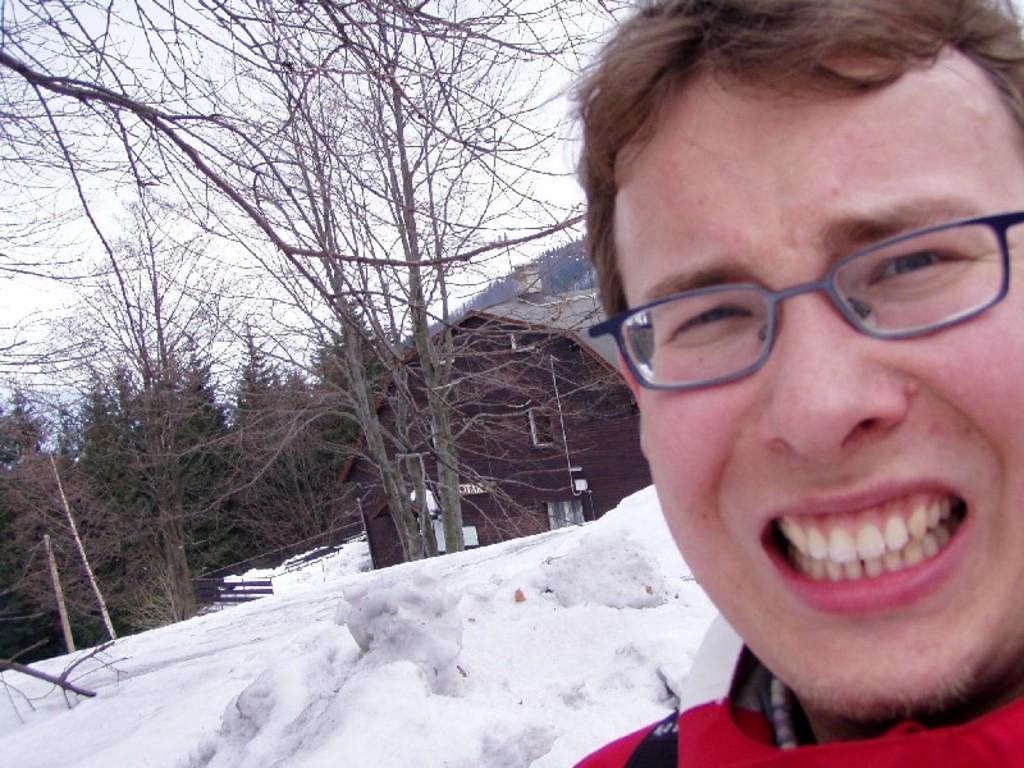Could you give a brief overview of what you see in this image? As we can see in the image there is snow, trees, sky and a man wearing red color jacket. 